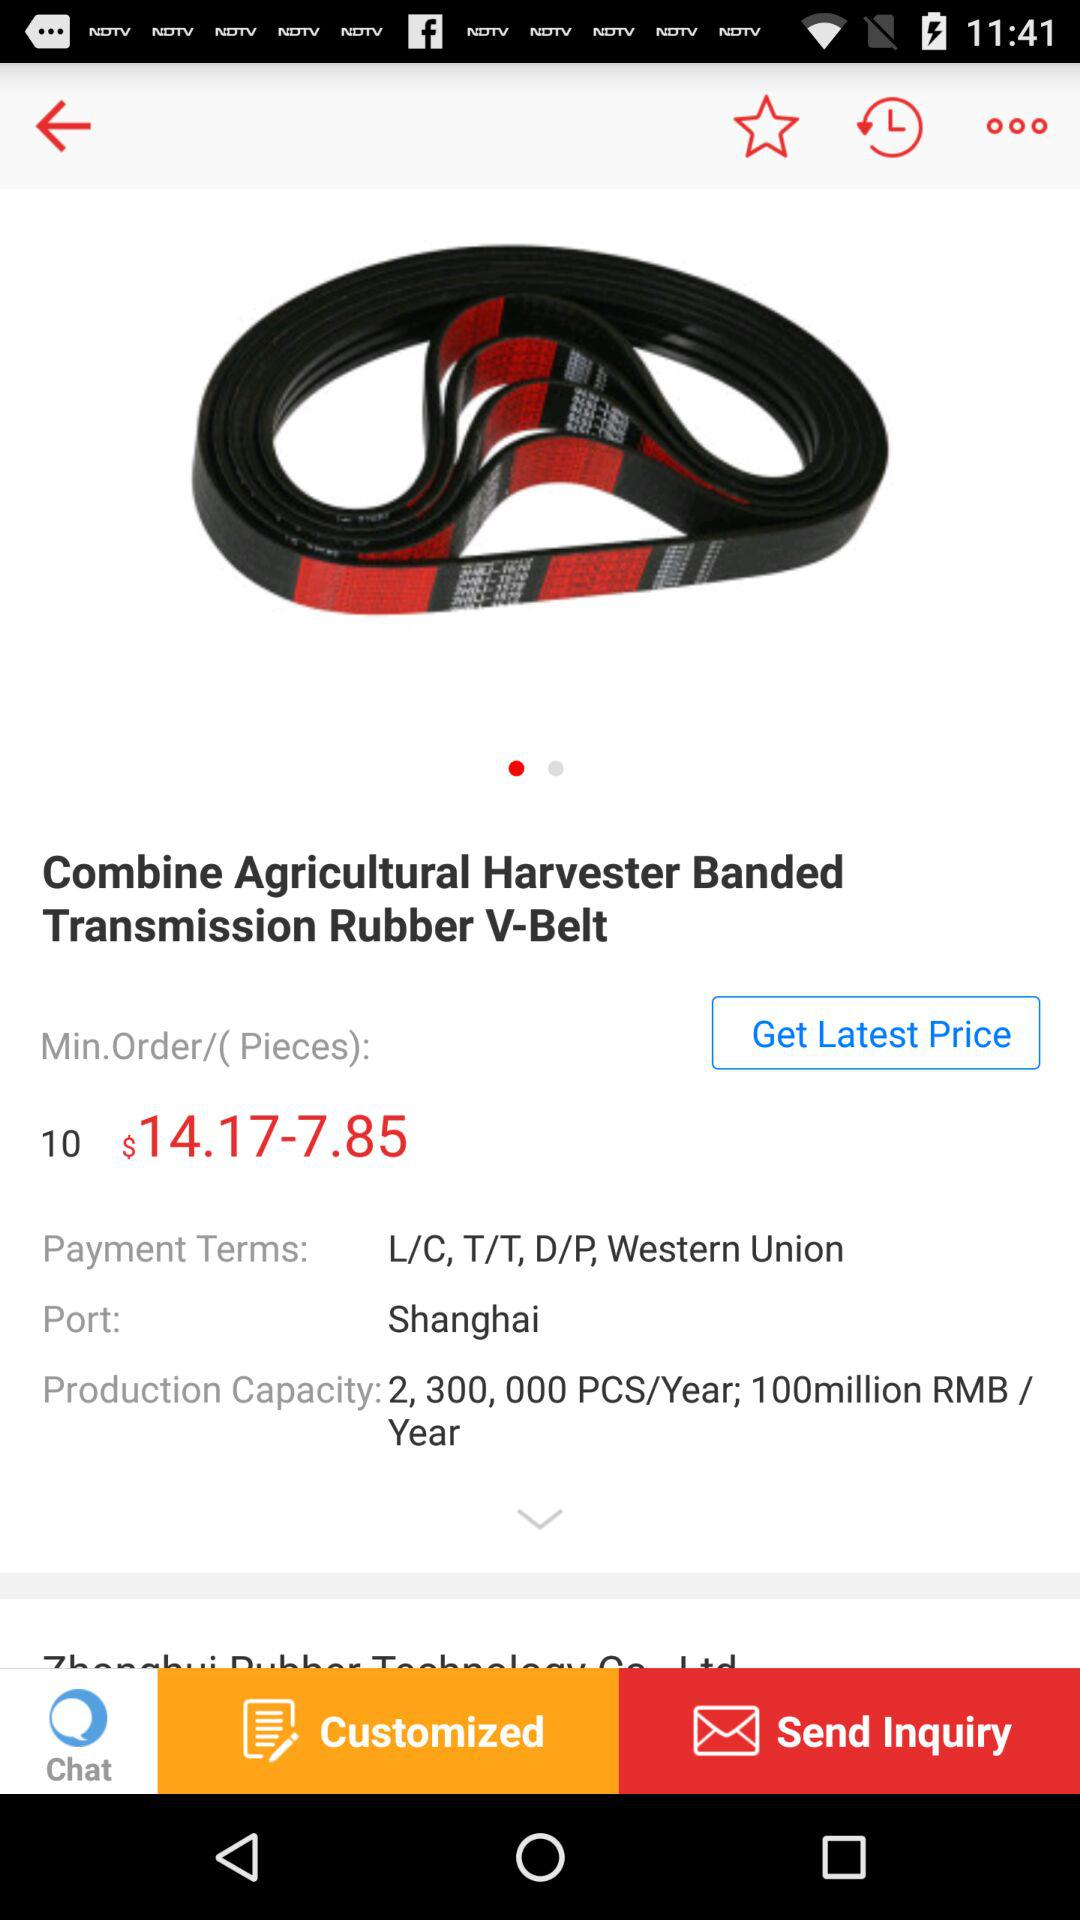What is the minimum order quantity?
Answer the question using a single word or phrase. 10 